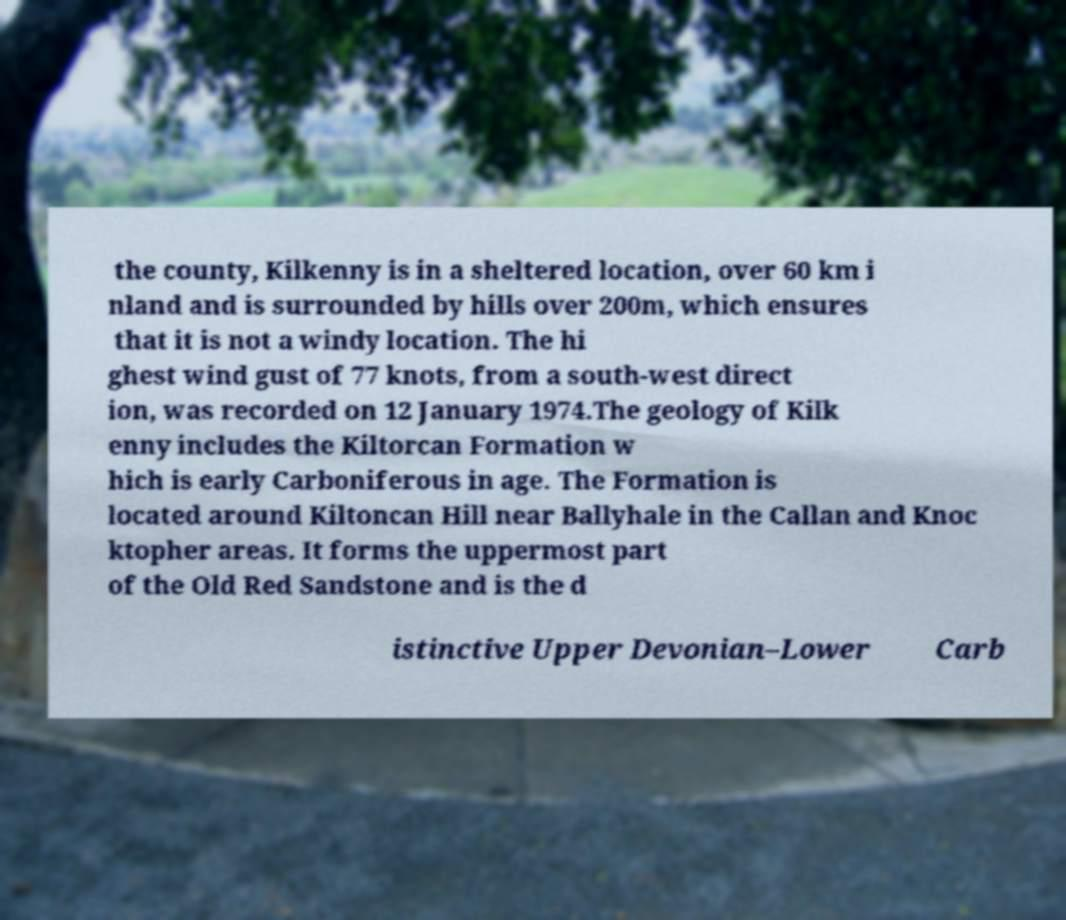Could you extract and type out the text from this image? the county, Kilkenny is in a sheltered location, over 60 km i nland and is surrounded by hills over 200m, which ensures that it is not a windy location. The hi ghest wind gust of 77 knots, from a south-west direct ion, was recorded on 12 January 1974.The geology of Kilk enny includes the Kiltorcan Formation w hich is early Carboniferous in age. The Formation is located around Kiltoncan Hill near Ballyhale in the Callan and Knoc ktopher areas. It forms the uppermost part of the Old Red Sandstone and is the d istinctive Upper Devonian–Lower Carb 